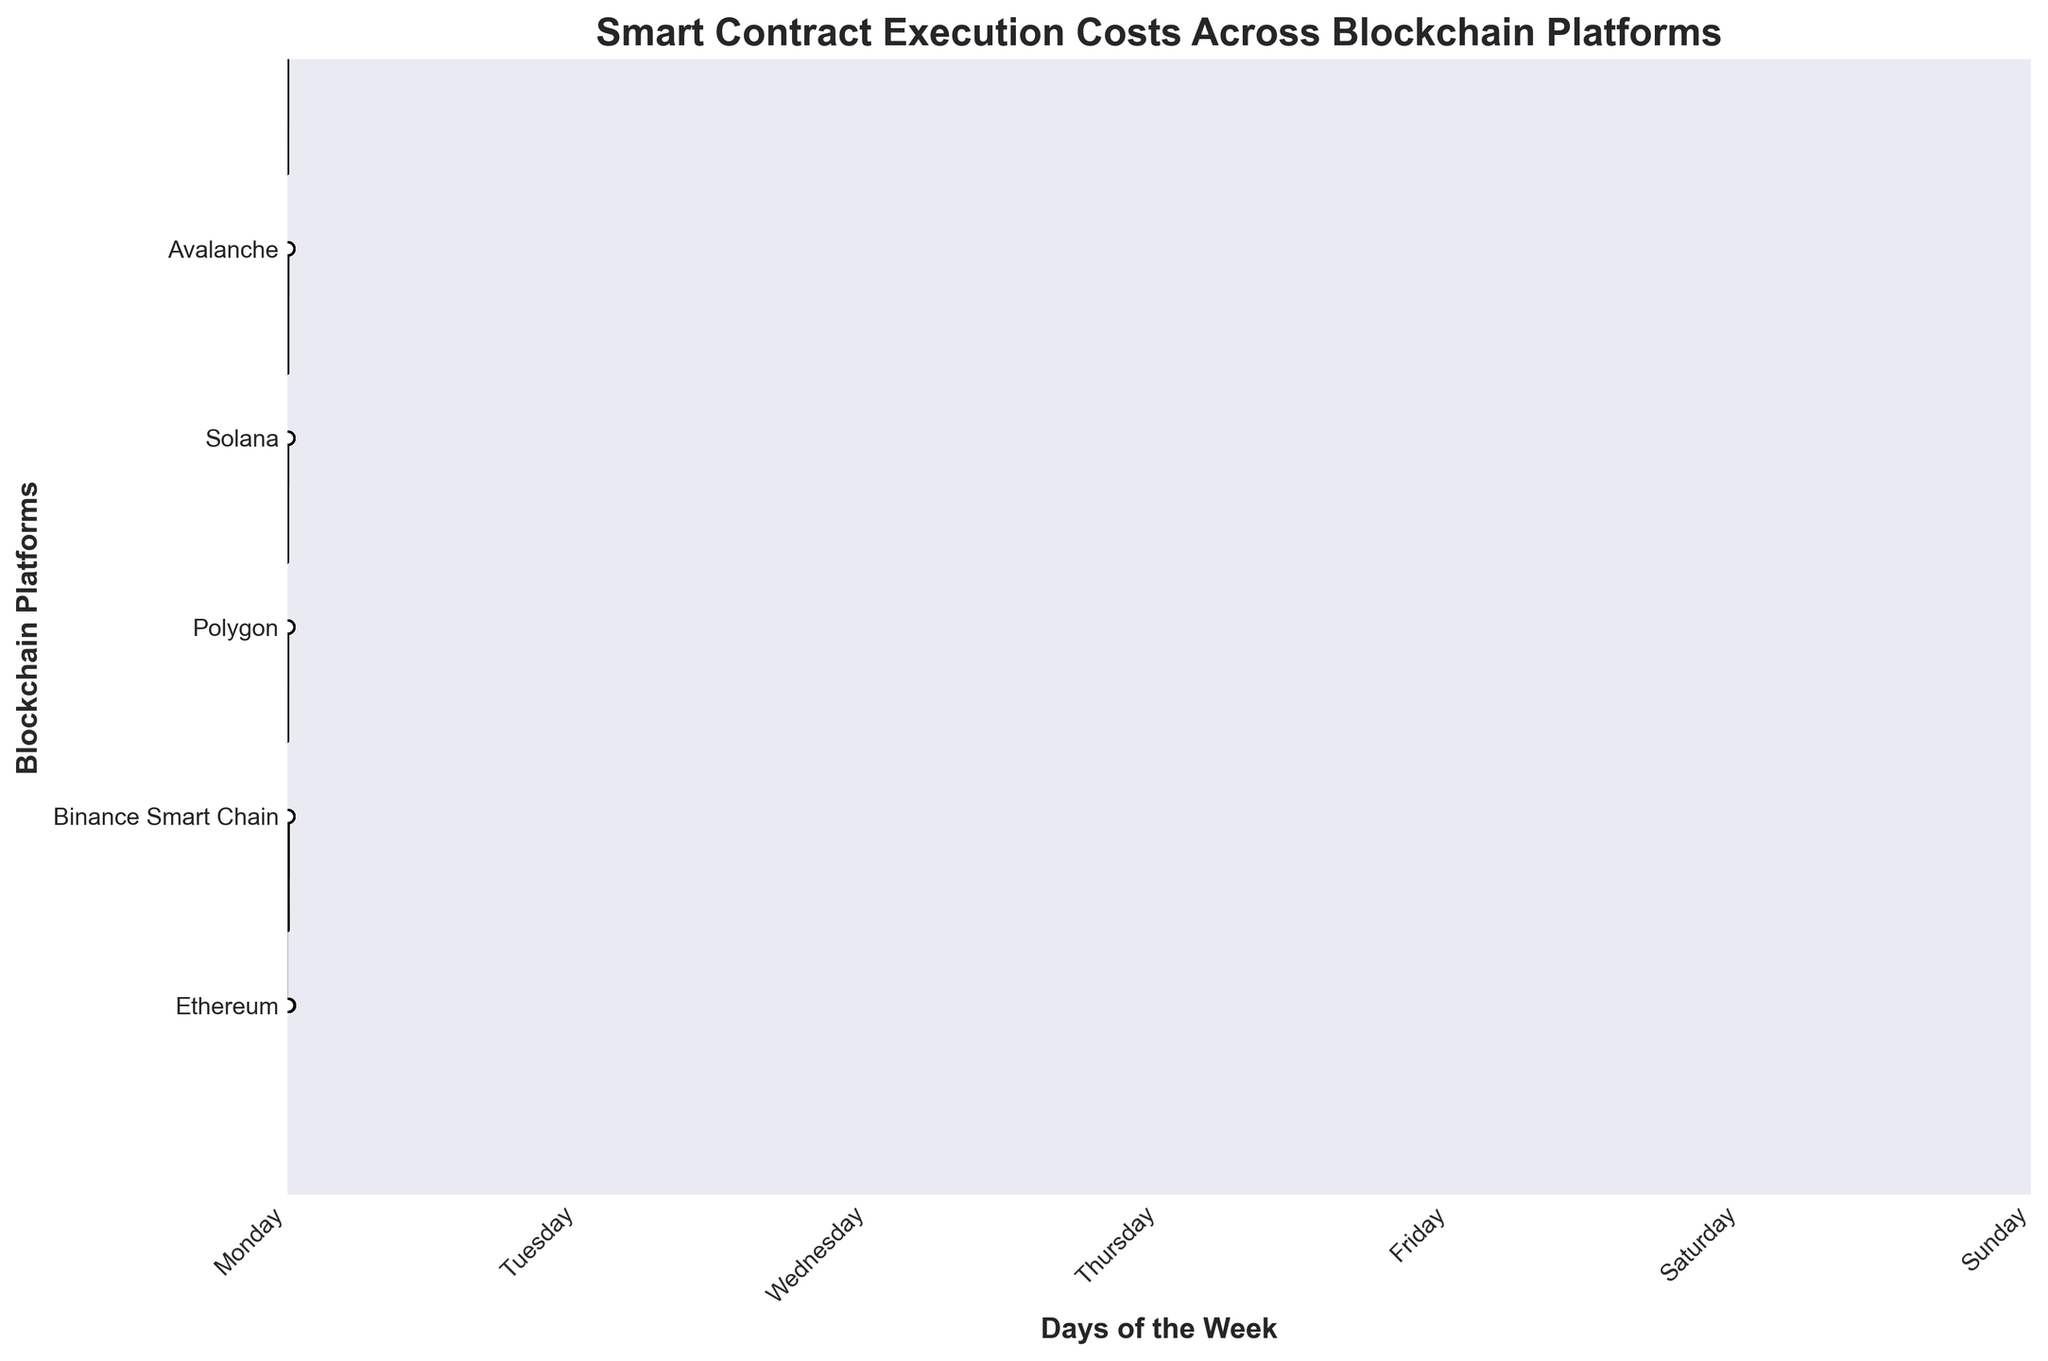How many blockchain platforms are compared in this figure? Count the unique labels on the y-axis which show the names of different blockchain platforms.
Answer: 5 What day of the week shows the highest execution cost for Ethereum? Identify the peak in the Ridgeline plot for Ethereum. The peak is highest on Friday.
Answer: Friday How does the execution cost on Binance Smart Chain change throughout the week? Observe the scatter points for Binance Smart Chain on each day and note the trend. The cost starts low on Monday, peaks on Friday, and then slightly decreases by Sunday.
Answer: Decreases, peaks on Friday, then decreases Which blockchain platform has the lowest execution cost, and on what days? Identify the Ridgeline plot with the lowest values. Solana has the lowest execution costs, with the lowest measurements on Monday and Sunday.
Answer: Solana, Monday and Sunday Compare the execution costs of Ethereum and Polygon on Wednesday. Locate the scatter points for Ethereum and Polygon on Wednesday in the Ridgeline plots. Ethereum has a much higher cost compared to Polygon.
Answer: Ethereum is higher than Polygon On which day does Solana have its highest execution cost? Look at the scatter points and peaks for Solana. The highest is on Friday.
Answer: Friday What is the general trend of execution costs on Avalanche during the week? Follow the scatter points and shapes of the Ridgeline plot for Avalanche across the days of the week. The cost generally increases towards Friday and then decreases slightly over the weekend.
Answer: Increases towards Friday, then decreases Among Ethereum, Binance Smart Chain, and Avalanche, which two platforms have the most similar cost patterns throughout the week? Compare the shapes and scatter points across the week for these platforms. Binance Smart Chain and Avalanche have more similar patterns compared to Ethereum.
Answer: Binance Smart Chain and Avalanche Does any blockchain platform show a consistent execution cost throughout the week? Look for a Ridgeline plot where the scatter points and density do not vary much across the week. Solana has a nearly flat pattern indicating consistent cost.
Answer: Solana Which blockchain platform appears the most cost-effective, and how is it visually represented? Identify the Ridgeline plot with the lowest points and densities. Solana, with relatively low execution costs throughout the week, thus visually represented by the lowest plotted values.
Answer: Solana, lowest plotted values 